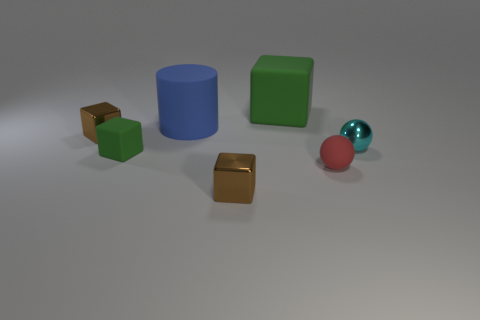Is the color of the matte cube that is in front of the tiny cyan metal thing the same as the large matte block?
Provide a succinct answer. Yes. What is the material of the small thing that is in front of the tiny cyan ball and on the left side of the big cylinder?
Provide a succinct answer. Rubber. How big is the red thing?
Keep it short and to the point. Small. Do the large rubber block and the rubber block in front of the cyan metallic ball have the same color?
Your answer should be compact. Yes. How many other things are the same color as the small rubber sphere?
Keep it short and to the point. 0. There is a metal block in front of the small metal sphere; does it have the same size as the green matte cube that is behind the small cyan shiny object?
Make the answer very short. No. What is the color of the small sphere that is behind the red matte ball?
Your response must be concise. Cyan. Is the number of big green rubber things that are to the right of the cyan shiny object less than the number of tiny brown things?
Make the answer very short. Yes. Are the tiny red sphere and the blue cylinder made of the same material?
Offer a very short reply. Yes. There is a cyan metal thing that is the same shape as the tiny red rubber object; what is its size?
Give a very brief answer. Small. 